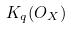Convert formula to latex. <formula><loc_0><loc_0><loc_500><loc_500>K _ { q } ( O _ { X } )</formula> 